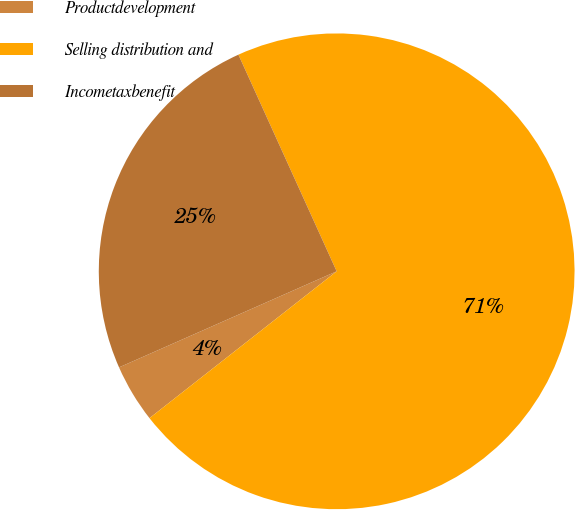<chart> <loc_0><loc_0><loc_500><loc_500><pie_chart><fcel>Productdevelopment<fcel>Selling distribution and<fcel>Incometaxbenefit<nl><fcel>3.97%<fcel>71.19%<fcel>24.84%<nl></chart> 